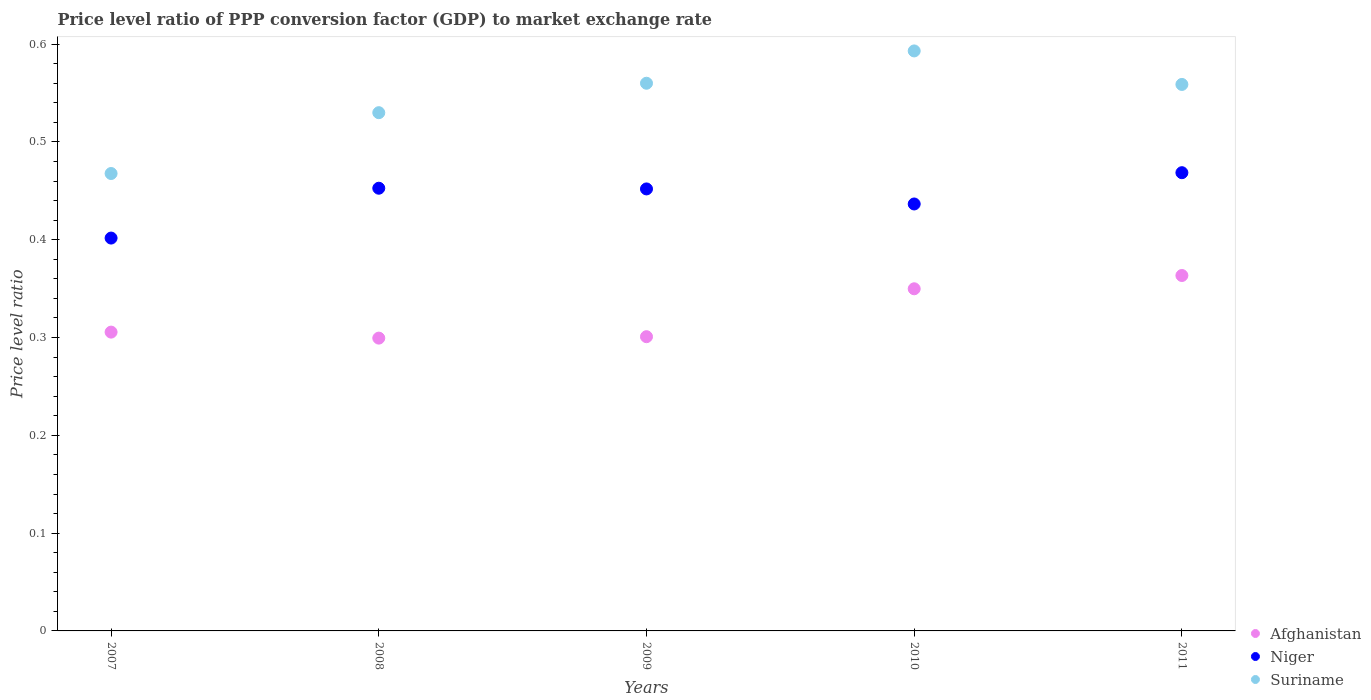How many different coloured dotlines are there?
Give a very brief answer. 3. What is the price level ratio in Suriname in 2009?
Offer a very short reply. 0.56. Across all years, what is the maximum price level ratio in Afghanistan?
Ensure brevity in your answer.  0.36. Across all years, what is the minimum price level ratio in Suriname?
Your answer should be very brief. 0.47. In which year was the price level ratio in Niger maximum?
Ensure brevity in your answer.  2011. What is the total price level ratio in Suriname in the graph?
Offer a terse response. 2.71. What is the difference between the price level ratio in Niger in 2007 and that in 2011?
Ensure brevity in your answer.  -0.07. What is the difference between the price level ratio in Afghanistan in 2009 and the price level ratio in Niger in 2007?
Make the answer very short. -0.1. What is the average price level ratio in Suriname per year?
Ensure brevity in your answer.  0.54. In the year 2007, what is the difference between the price level ratio in Niger and price level ratio in Afghanistan?
Offer a terse response. 0.1. In how many years, is the price level ratio in Niger greater than 0.5?
Your answer should be very brief. 0. What is the ratio of the price level ratio in Afghanistan in 2010 to that in 2011?
Offer a very short reply. 0.96. What is the difference between the highest and the second highest price level ratio in Suriname?
Ensure brevity in your answer.  0.03. What is the difference between the highest and the lowest price level ratio in Afghanistan?
Your answer should be very brief. 0.06. In how many years, is the price level ratio in Suriname greater than the average price level ratio in Suriname taken over all years?
Your response must be concise. 3. Is it the case that in every year, the sum of the price level ratio in Niger and price level ratio in Suriname  is greater than the price level ratio in Afghanistan?
Your answer should be compact. Yes. Is the price level ratio in Afghanistan strictly greater than the price level ratio in Suriname over the years?
Offer a very short reply. No. How many years are there in the graph?
Provide a short and direct response. 5. Are the values on the major ticks of Y-axis written in scientific E-notation?
Your answer should be very brief. No. Does the graph contain grids?
Provide a short and direct response. No. How many legend labels are there?
Your answer should be very brief. 3. How are the legend labels stacked?
Your answer should be compact. Vertical. What is the title of the graph?
Offer a terse response. Price level ratio of PPP conversion factor (GDP) to market exchange rate. What is the label or title of the Y-axis?
Give a very brief answer. Price level ratio. What is the Price level ratio of Afghanistan in 2007?
Ensure brevity in your answer.  0.31. What is the Price level ratio in Niger in 2007?
Make the answer very short. 0.4. What is the Price level ratio in Suriname in 2007?
Provide a short and direct response. 0.47. What is the Price level ratio in Afghanistan in 2008?
Provide a short and direct response. 0.3. What is the Price level ratio in Niger in 2008?
Offer a terse response. 0.45. What is the Price level ratio of Suriname in 2008?
Offer a very short reply. 0.53. What is the Price level ratio in Afghanistan in 2009?
Provide a short and direct response. 0.3. What is the Price level ratio in Niger in 2009?
Offer a terse response. 0.45. What is the Price level ratio in Suriname in 2009?
Provide a short and direct response. 0.56. What is the Price level ratio of Afghanistan in 2010?
Provide a succinct answer. 0.35. What is the Price level ratio of Niger in 2010?
Ensure brevity in your answer.  0.44. What is the Price level ratio of Suriname in 2010?
Your answer should be very brief. 0.59. What is the Price level ratio of Afghanistan in 2011?
Your answer should be very brief. 0.36. What is the Price level ratio in Niger in 2011?
Keep it short and to the point. 0.47. What is the Price level ratio of Suriname in 2011?
Provide a succinct answer. 0.56. Across all years, what is the maximum Price level ratio in Afghanistan?
Offer a terse response. 0.36. Across all years, what is the maximum Price level ratio in Niger?
Provide a short and direct response. 0.47. Across all years, what is the maximum Price level ratio in Suriname?
Ensure brevity in your answer.  0.59. Across all years, what is the minimum Price level ratio of Afghanistan?
Your answer should be compact. 0.3. Across all years, what is the minimum Price level ratio in Niger?
Offer a very short reply. 0.4. Across all years, what is the minimum Price level ratio in Suriname?
Ensure brevity in your answer.  0.47. What is the total Price level ratio of Afghanistan in the graph?
Offer a terse response. 1.62. What is the total Price level ratio in Niger in the graph?
Ensure brevity in your answer.  2.21. What is the total Price level ratio of Suriname in the graph?
Your response must be concise. 2.71. What is the difference between the Price level ratio in Afghanistan in 2007 and that in 2008?
Ensure brevity in your answer.  0.01. What is the difference between the Price level ratio of Niger in 2007 and that in 2008?
Your response must be concise. -0.05. What is the difference between the Price level ratio in Suriname in 2007 and that in 2008?
Make the answer very short. -0.06. What is the difference between the Price level ratio of Afghanistan in 2007 and that in 2009?
Your answer should be compact. 0. What is the difference between the Price level ratio of Niger in 2007 and that in 2009?
Offer a terse response. -0.05. What is the difference between the Price level ratio in Suriname in 2007 and that in 2009?
Offer a terse response. -0.09. What is the difference between the Price level ratio of Afghanistan in 2007 and that in 2010?
Offer a very short reply. -0.04. What is the difference between the Price level ratio of Niger in 2007 and that in 2010?
Provide a short and direct response. -0.03. What is the difference between the Price level ratio in Suriname in 2007 and that in 2010?
Provide a short and direct response. -0.13. What is the difference between the Price level ratio in Afghanistan in 2007 and that in 2011?
Offer a very short reply. -0.06. What is the difference between the Price level ratio in Niger in 2007 and that in 2011?
Make the answer very short. -0.07. What is the difference between the Price level ratio of Suriname in 2007 and that in 2011?
Offer a very short reply. -0.09. What is the difference between the Price level ratio in Afghanistan in 2008 and that in 2009?
Your answer should be compact. -0. What is the difference between the Price level ratio in Niger in 2008 and that in 2009?
Make the answer very short. 0. What is the difference between the Price level ratio of Suriname in 2008 and that in 2009?
Your answer should be compact. -0.03. What is the difference between the Price level ratio in Afghanistan in 2008 and that in 2010?
Your answer should be compact. -0.05. What is the difference between the Price level ratio of Niger in 2008 and that in 2010?
Your response must be concise. 0.02. What is the difference between the Price level ratio in Suriname in 2008 and that in 2010?
Offer a terse response. -0.06. What is the difference between the Price level ratio in Afghanistan in 2008 and that in 2011?
Provide a short and direct response. -0.06. What is the difference between the Price level ratio of Niger in 2008 and that in 2011?
Make the answer very short. -0.02. What is the difference between the Price level ratio of Suriname in 2008 and that in 2011?
Ensure brevity in your answer.  -0.03. What is the difference between the Price level ratio in Afghanistan in 2009 and that in 2010?
Give a very brief answer. -0.05. What is the difference between the Price level ratio in Niger in 2009 and that in 2010?
Offer a very short reply. 0.02. What is the difference between the Price level ratio of Suriname in 2009 and that in 2010?
Provide a short and direct response. -0.03. What is the difference between the Price level ratio of Afghanistan in 2009 and that in 2011?
Your response must be concise. -0.06. What is the difference between the Price level ratio of Niger in 2009 and that in 2011?
Make the answer very short. -0.02. What is the difference between the Price level ratio in Suriname in 2009 and that in 2011?
Your answer should be compact. 0. What is the difference between the Price level ratio of Afghanistan in 2010 and that in 2011?
Your answer should be compact. -0.01. What is the difference between the Price level ratio in Niger in 2010 and that in 2011?
Your answer should be very brief. -0.03. What is the difference between the Price level ratio of Suriname in 2010 and that in 2011?
Provide a succinct answer. 0.03. What is the difference between the Price level ratio of Afghanistan in 2007 and the Price level ratio of Niger in 2008?
Offer a very short reply. -0.15. What is the difference between the Price level ratio of Afghanistan in 2007 and the Price level ratio of Suriname in 2008?
Ensure brevity in your answer.  -0.22. What is the difference between the Price level ratio in Niger in 2007 and the Price level ratio in Suriname in 2008?
Make the answer very short. -0.13. What is the difference between the Price level ratio of Afghanistan in 2007 and the Price level ratio of Niger in 2009?
Your answer should be compact. -0.15. What is the difference between the Price level ratio in Afghanistan in 2007 and the Price level ratio in Suriname in 2009?
Your answer should be very brief. -0.25. What is the difference between the Price level ratio in Niger in 2007 and the Price level ratio in Suriname in 2009?
Offer a very short reply. -0.16. What is the difference between the Price level ratio in Afghanistan in 2007 and the Price level ratio in Niger in 2010?
Your answer should be compact. -0.13. What is the difference between the Price level ratio of Afghanistan in 2007 and the Price level ratio of Suriname in 2010?
Keep it short and to the point. -0.29. What is the difference between the Price level ratio in Niger in 2007 and the Price level ratio in Suriname in 2010?
Your answer should be compact. -0.19. What is the difference between the Price level ratio of Afghanistan in 2007 and the Price level ratio of Niger in 2011?
Provide a short and direct response. -0.16. What is the difference between the Price level ratio of Afghanistan in 2007 and the Price level ratio of Suriname in 2011?
Provide a succinct answer. -0.25. What is the difference between the Price level ratio of Niger in 2007 and the Price level ratio of Suriname in 2011?
Your response must be concise. -0.16. What is the difference between the Price level ratio of Afghanistan in 2008 and the Price level ratio of Niger in 2009?
Give a very brief answer. -0.15. What is the difference between the Price level ratio in Afghanistan in 2008 and the Price level ratio in Suriname in 2009?
Give a very brief answer. -0.26. What is the difference between the Price level ratio in Niger in 2008 and the Price level ratio in Suriname in 2009?
Provide a short and direct response. -0.11. What is the difference between the Price level ratio in Afghanistan in 2008 and the Price level ratio in Niger in 2010?
Keep it short and to the point. -0.14. What is the difference between the Price level ratio of Afghanistan in 2008 and the Price level ratio of Suriname in 2010?
Offer a very short reply. -0.29. What is the difference between the Price level ratio in Niger in 2008 and the Price level ratio in Suriname in 2010?
Give a very brief answer. -0.14. What is the difference between the Price level ratio of Afghanistan in 2008 and the Price level ratio of Niger in 2011?
Your answer should be compact. -0.17. What is the difference between the Price level ratio in Afghanistan in 2008 and the Price level ratio in Suriname in 2011?
Your answer should be very brief. -0.26. What is the difference between the Price level ratio in Niger in 2008 and the Price level ratio in Suriname in 2011?
Provide a short and direct response. -0.11. What is the difference between the Price level ratio of Afghanistan in 2009 and the Price level ratio of Niger in 2010?
Your answer should be very brief. -0.14. What is the difference between the Price level ratio in Afghanistan in 2009 and the Price level ratio in Suriname in 2010?
Offer a terse response. -0.29. What is the difference between the Price level ratio of Niger in 2009 and the Price level ratio of Suriname in 2010?
Ensure brevity in your answer.  -0.14. What is the difference between the Price level ratio of Afghanistan in 2009 and the Price level ratio of Niger in 2011?
Give a very brief answer. -0.17. What is the difference between the Price level ratio in Afghanistan in 2009 and the Price level ratio in Suriname in 2011?
Offer a terse response. -0.26. What is the difference between the Price level ratio of Niger in 2009 and the Price level ratio of Suriname in 2011?
Ensure brevity in your answer.  -0.11. What is the difference between the Price level ratio in Afghanistan in 2010 and the Price level ratio in Niger in 2011?
Keep it short and to the point. -0.12. What is the difference between the Price level ratio of Afghanistan in 2010 and the Price level ratio of Suriname in 2011?
Your response must be concise. -0.21. What is the difference between the Price level ratio in Niger in 2010 and the Price level ratio in Suriname in 2011?
Provide a short and direct response. -0.12. What is the average Price level ratio in Afghanistan per year?
Make the answer very short. 0.32. What is the average Price level ratio in Niger per year?
Offer a terse response. 0.44. What is the average Price level ratio in Suriname per year?
Your response must be concise. 0.54. In the year 2007, what is the difference between the Price level ratio of Afghanistan and Price level ratio of Niger?
Your answer should be compact. -0.1. In the year 2007, what is the difference between the Price level ratio in Afghanistan and Price level ratio in Suriname?
Provide a succinct answer. -0.16. In the year 2007, what is the difference between the Price level ratio of Niger and Price level ratio of Suriname?
Your answer should be very brief. -0.07. In the year 2008, what is the difference between the Price level ratio in Afghanistan and Price level ratio in Niger?
Make the answer very short. -0.15. In the year 2008, what is the difference between the Price level ratio of Afghanistan and Price level ratio of Suriname?
Make the answer very short. -0.23. In the year 2008, what is the difference between the Price level ratio of Niger and Price level ratio of Suriname?
Make the answer very short. -0.08. In the year 2009, what is the difference between the Price level ratio in Afghanistan and Price level ratio in Niger?
Provide a succinct answer. -0.15. In the year 2009, what is the difference between the Price level ratio of Afghanistan and Price level ratio of Suriname?
Provide a succinct answer. -0.26. In the year 2009, what is the difference between the Price level ratio of Niger and Price level ratio of Suriname?
Offer a terse response. -0.11. In the year 2010, what is the difference between the Price level ratio of Afghanistan and Price level ratio of Niger?
Ensure brevity in your answer.  -0.09. In the year 2010, what is the difference between the Price level ratio of Afghanistan and Price level ratio of Suriname?
Give a very brief answer. -0.24. In the year 2010, what is the difference between the Price level ratio in Niger and Price level ratio in Suriname?
Give a very brief answer. -0.16. In the year 2011, what is the difference between the Price level ratio in Afghanistan and Price level ratio in Niger?
Give a very brief answer. -0.11. In the year 2011, what is the difference between the Price level ratio of Afghanistan and Price level ratio of Suriname?
Give a very brief answer. -0.2. In the year 2011, what is the difference between the Price level ratio in Niger and Price level ratio in Suriname?
Offer a terse response. -0.09. What is the ratio of the Price level ratio of Afghanistan in 2007 to that in 2008?
Keep it short and to the point. 1.02. What is the ratio of the Price level ratio in Niger in 2007 to that in 2008?
Ensure brevity in your answer.  0.89. What is the ratio of the Price level ratio in Suriname in 2007 to that in 2008?
Your response must be concise. 0.88. What is the ratio of the Price level ratio of Afghanistan in 2007 to that in 2009?
Ensure brevity in your answer.  1.02. What is the ratio of the Price level ratio of Niger in 2007 to that in 2009?
Your answer should be compact. 0.89. What is the ratio of the Price level ratio in Suriname in 2007 to that in 2009?
Your response must be concise. 0.84. What is the ratio of the Price level ratio in Afghanistan in 2007 to that in 2010?
Your answer should be very brief. 0.87. What is the ratio of the Price level ratio in Niger in 2007 to that in 2010?
Your answer should be very brief. 0.92. What is the ratio of the Price level ratio in Suriname in 2007 to that in 2010?
Your response must be concise. 0.79. What is the ratio of the Price level ratio in Afghanistan in 2007 to that in 2011?
Provide a short and direct response. 0.84. What is the ratio of the Price level ratio in Niger in 2007 to that in 2011?
Your response must be concise. 0.86. What is the ratio of the Price level ratio in Suriname in 2007 to that in 2011?
Your answer should be very brief. 0.84. What is the ratio of the Price level ratio in Afghanistan in 2008 to that in 2009?
Offer a terse response. 1. What is the ratio of the Price level ratio in Suriname in 2008 to that in 2009?
Ensure brevity in your answer.  0.95. What is the ratio of the Price level ratio of Afghanistan in 2008 to that in 2010?
Provide a short and direct response. 0.86. What is the ratio of the Price level ratio of Niger in 2008 to that in 2010?
Offer a terse response. 1.04. What is the ratio of the Price level ratio in Suriname in 2008 to that in 2010?
Provide a short and direct response. 0.89. What is the ratio of the Price level ratio of Afghanistan in 2008 to that in 2011?
Your response must be concise. 0.82. What is the ratio of the Price level ratio in Niger in 2008 to that in 2011?
Offer a very short reply. 0.97. What is the ratio of the Price level ratio of Suriname in 2008 to that in 2011?
Ensure brevity in your answer.  0.95. What is the ratio of the Price level ratio in Afghanistan in 2009 to that in 2010?
Ensure brevity in your answer.  0.86. What is the ratio of the Price level ratio in Niger in 2009 to that in 2010?
Keep it short and to the point. 1.04. What is the ratio of the Price level ratio of Suriname in 2009 to that in 2010?
Your response must be concise. 0.94. What is the ratio of the Price level ratio of Afghanistan in 2009 to that in 2011?
Keep it short and to the point. 0.83. What is the ratio of the Price level ratio in Niger in 2009 to that in 2011?
Make the answer very short. 0.96. What is the ratio of the Price level ratio in Afghanistan in 2010 to that in 2011?
Offer a very short reply. 0.96. What is the ratio of the Price level ratio in Niger in 2010 to that in 2011?
Give a very brief answer. 0.93. What is the ratio of the Price level ratio of Suriname in 2010 to that in 2011?
Offer a very short reply. 1.06. What is the difference between the highest and the second highest Price level ratio in Afghanistan?
Ensure brevity in your answer.  0.01. What is the difference between the highest and the second highest Price level ratio of Niger?
Your answer should be very brief. 0.02. What is the difference between the highest and the second highest Price level ratio of Suriname?
Make the answer very short. 0.03. What is the difference between the highest and the lowest Price level ratio of Afghanistan?
Keep it short and to the point. 0.06. What is the difference between the highest and the lowest Price level ratio in Niger?
Offer a terse response. 0.07. What is the difference between the highest and the lowest Price level ratio in Suriname?
Offer a very short reply. 0.13. 